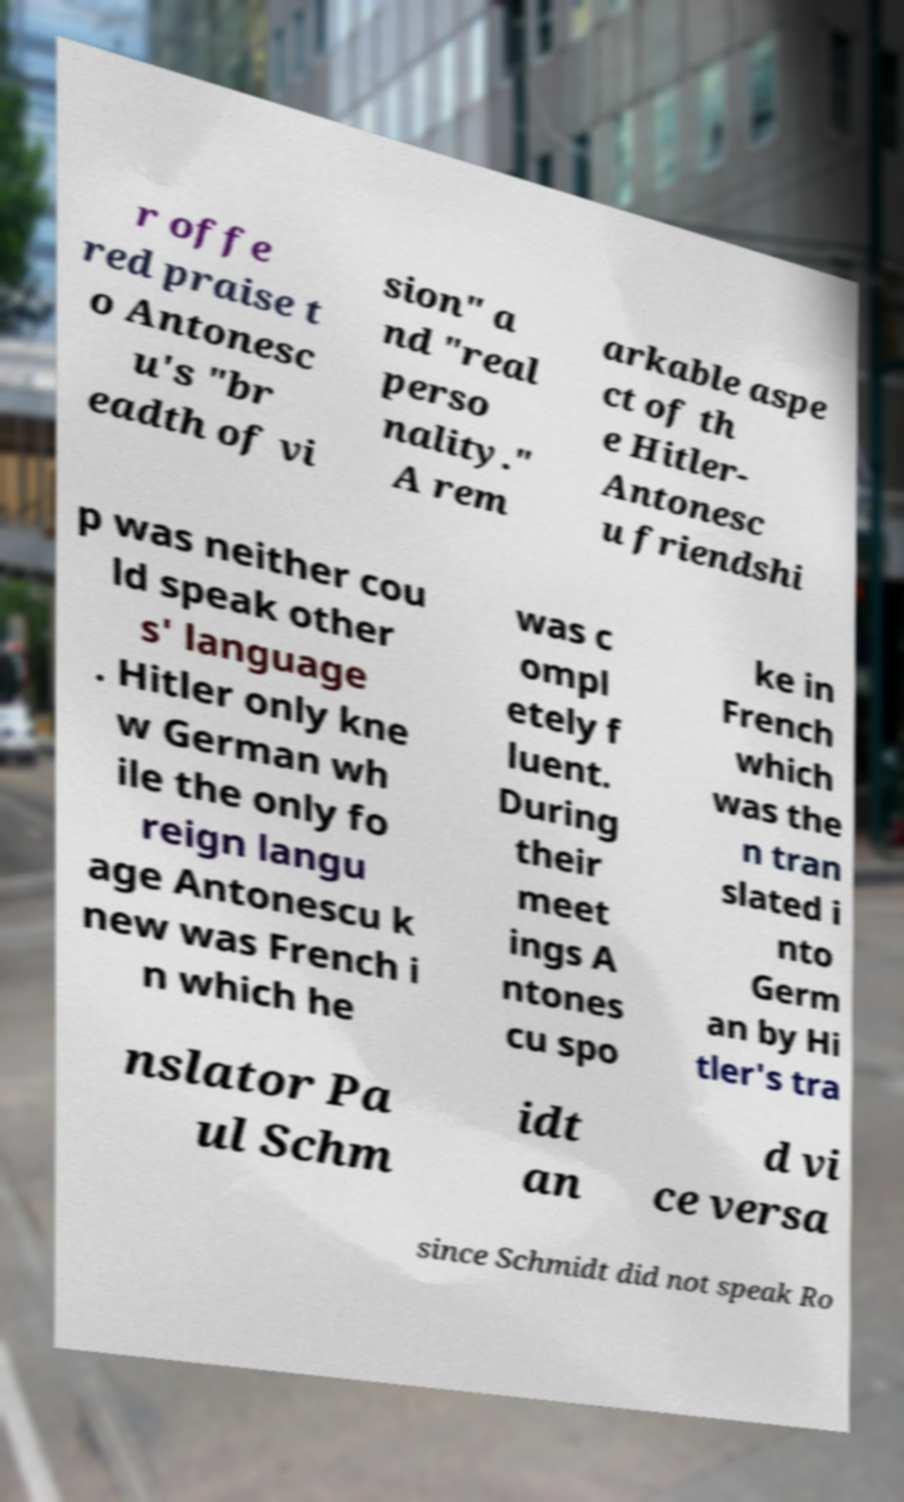There's text embedded in this image that I need extracted. Can you transcribe it verbatim? r offe red praise t o Antonesc u's "br eadth of vi sion" a nd "real perso nality." A rem arkable aspe ct of th e Hitler- Antonesc u friendshi p was neither cou ld speak other s' language . Hitler only kne w German wh ile the only fo reign langu age Antonescu k new was French i n which he was c ompl etely f luent. During their meet ings A ntones cu spo ke in French which was the n tran slated i nto Germ an by Hi tler's tra nslator Pa ul Schm idt an d vi ce versa since Schmidt did not speak Ro 